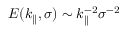Convert formula to latex. <formula><loc_0><loc_0><loc_500><loc_500>E ( k _ { \| } , \sigma ) \sim k _ { \| } ^ { - 2 } \sigma ^ { - 2 }</formula> 